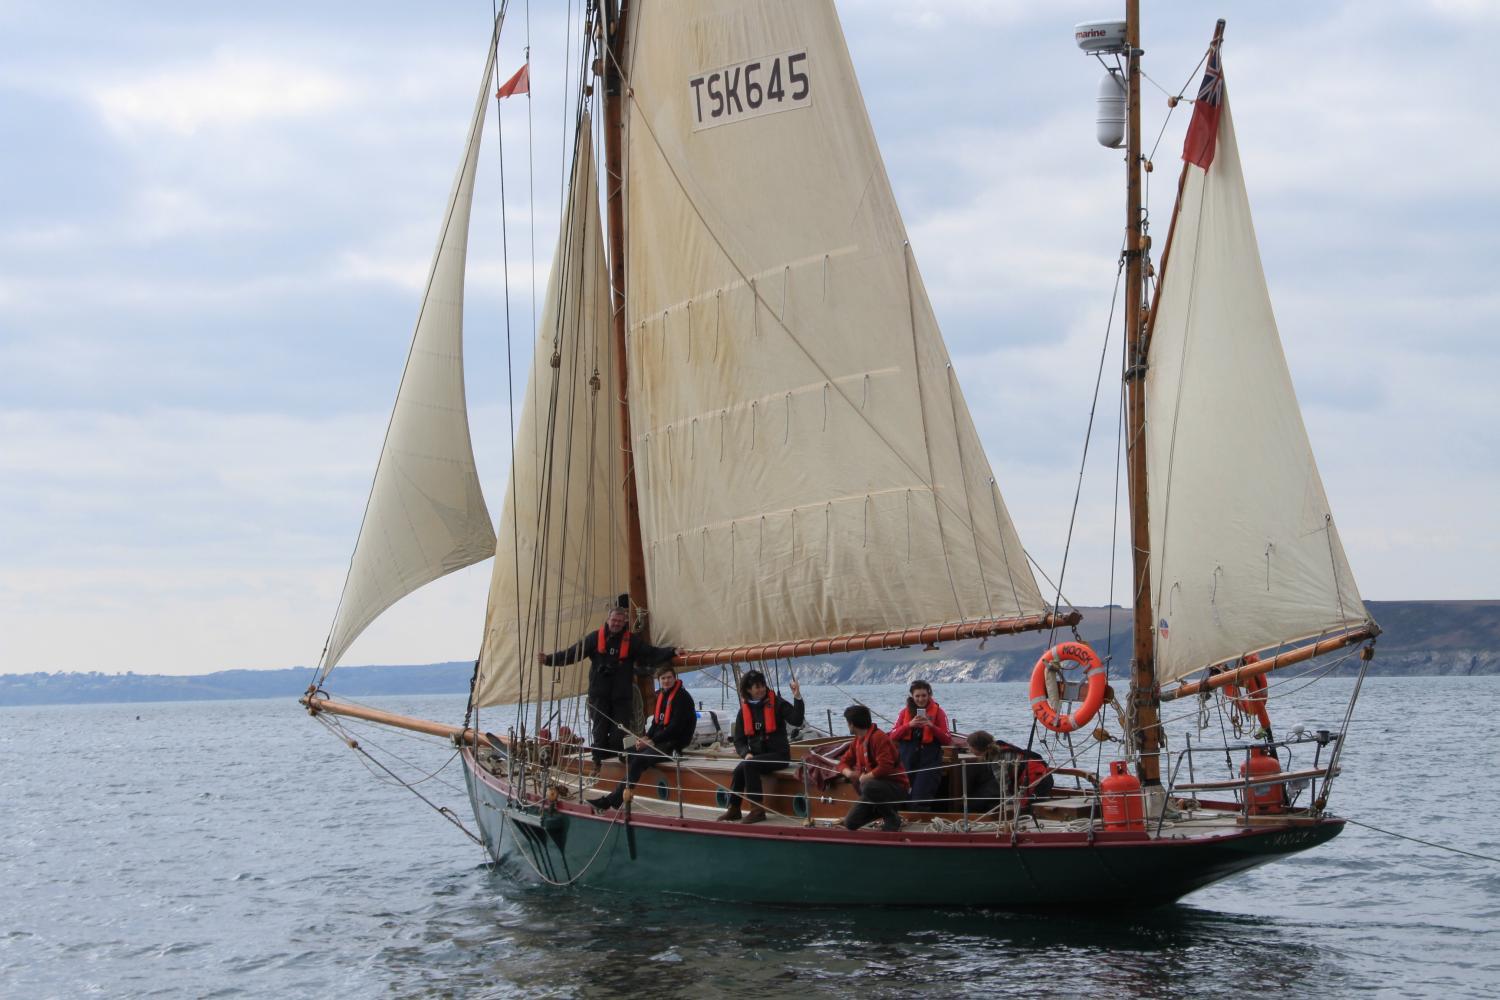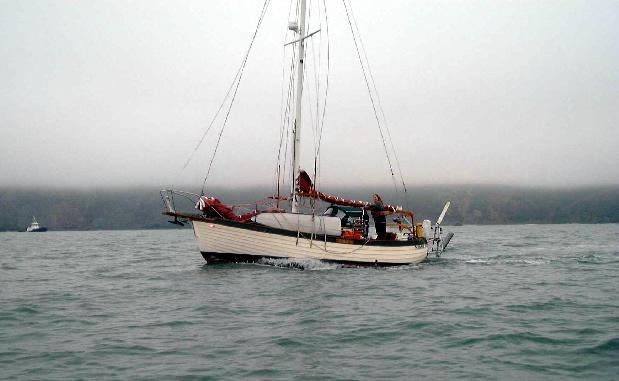The first image is the image on the left, the second image is the image on the right. Considering the images on both sides, is "One sailboat is on the open water with its sails folded down." valid? Answer yes or no. Yes. The first image is the image on the left, the second image is the image on the right. Evaluate the accuracy of this statement regarding the images: "The left and right image contains the same number of sailboats sailing with at least one with no sails out.". Is it true? Answer yes or no. Yes. 